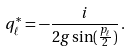<formula> <loc_0><loc_0><loc_500><loc_500>q _ { \ell } ^ { * } = - \frac { i } { 2 g \sin ( \frac { p _ { \ell } } { 2 } ) } \, .</formula> 